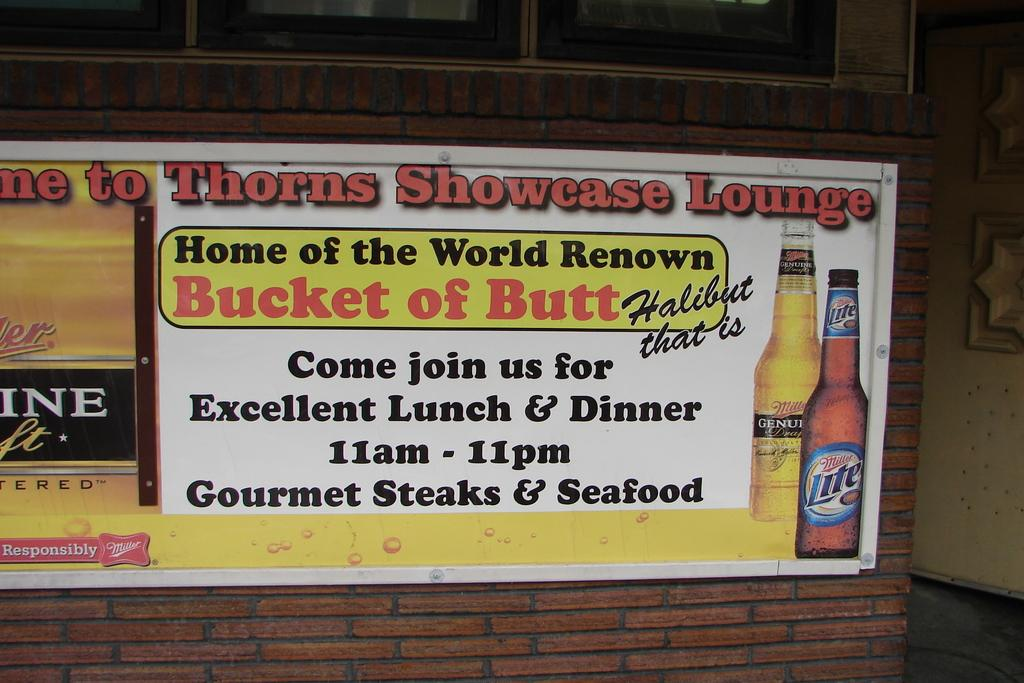<image>
Relay a brief, clear account of the picture shown. An advertisement for the home of the world renowned bucket of halibut with two bottles of beer pictured. 